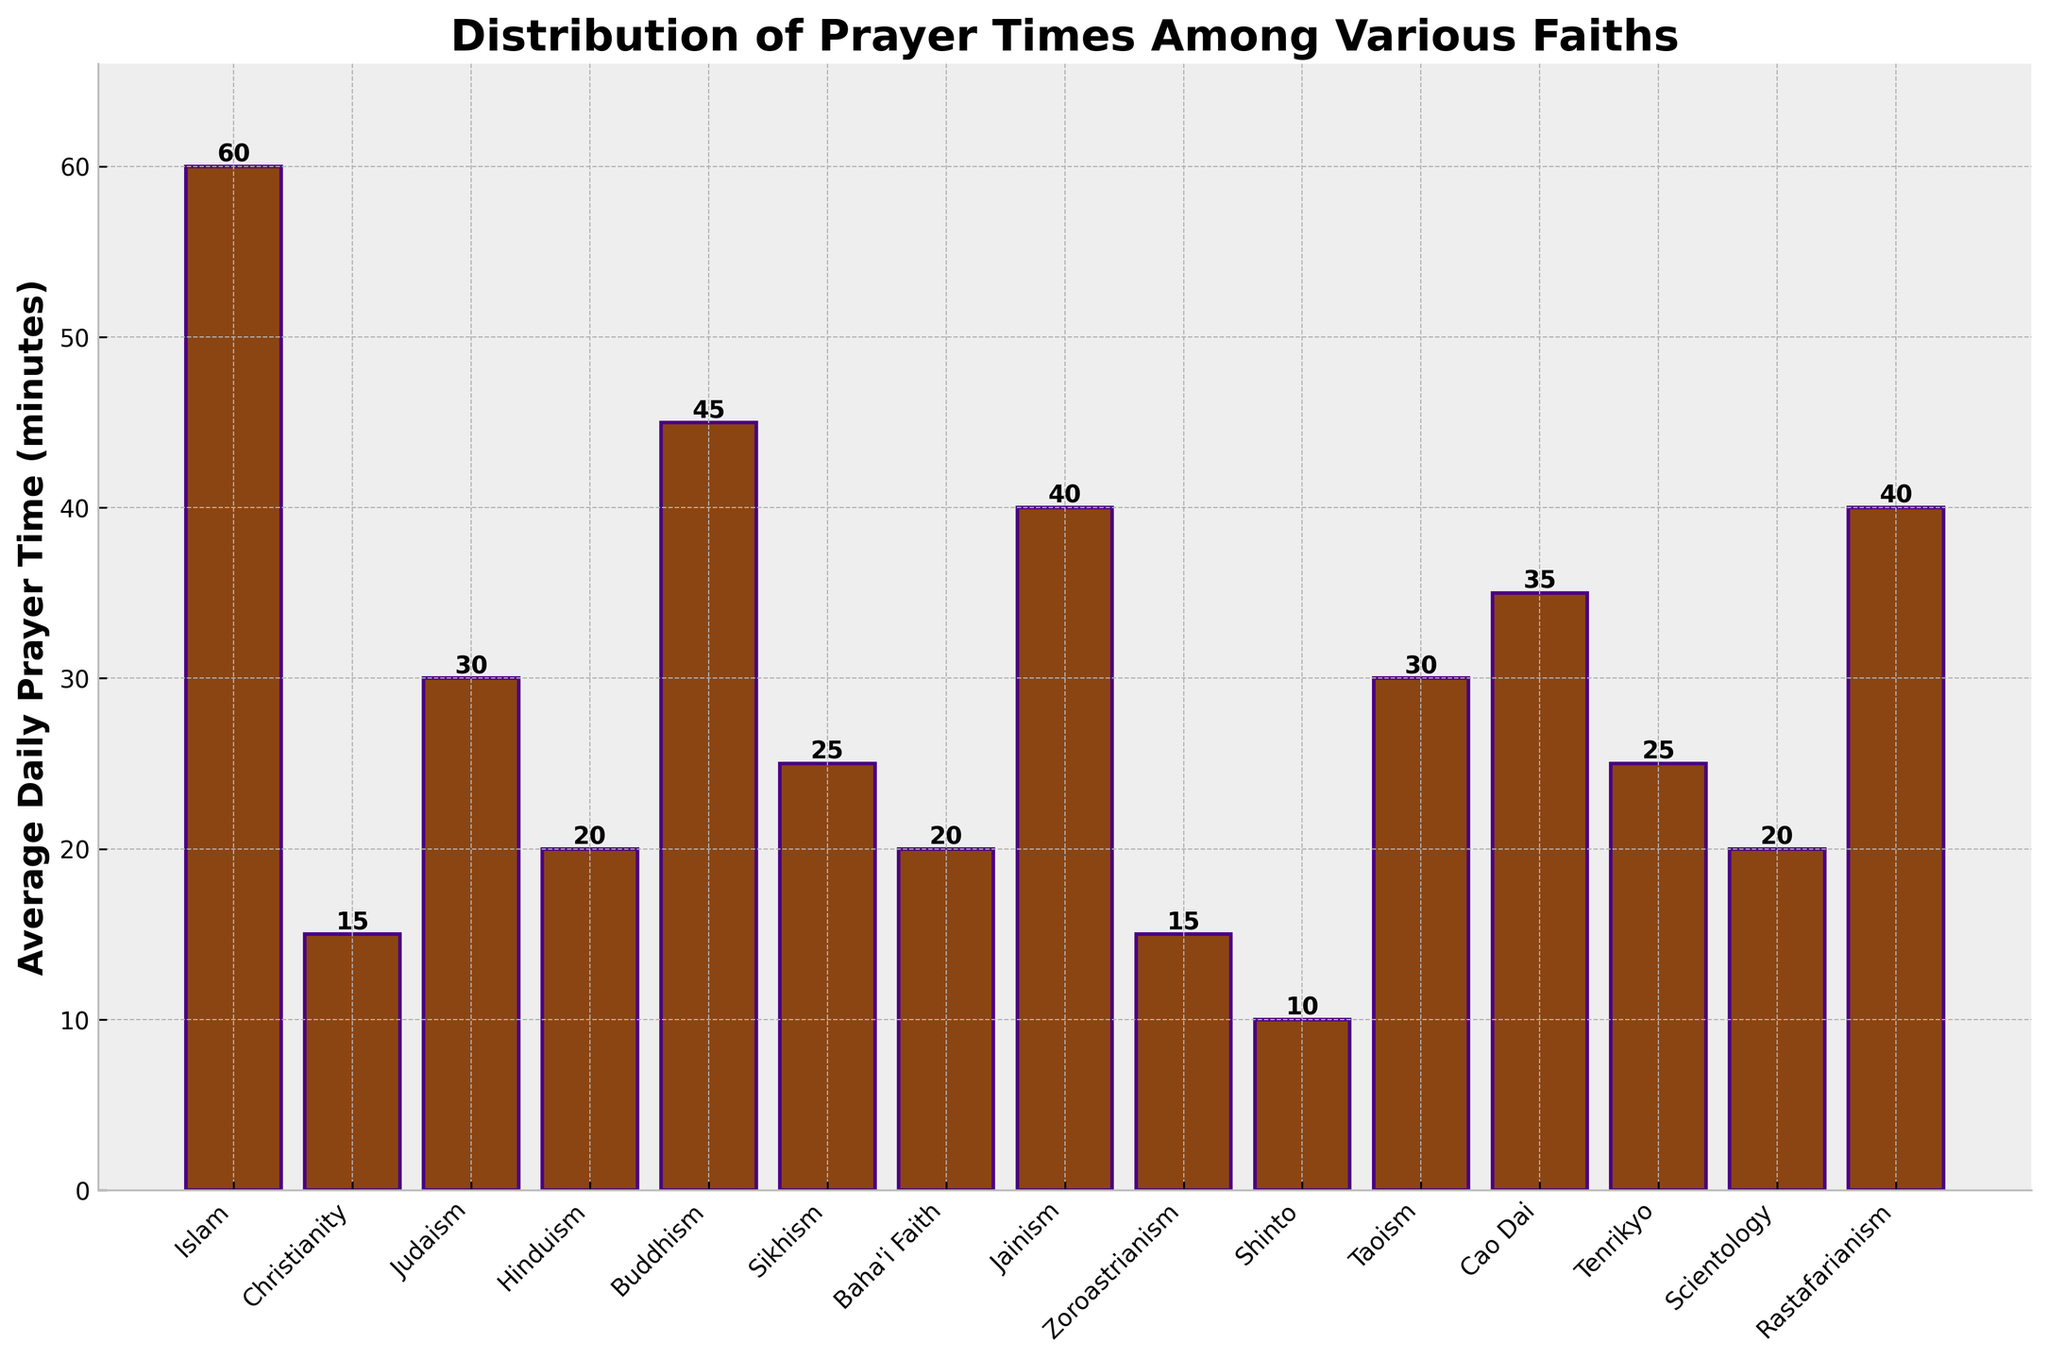What is the average daily prayer time for Islam? Look at the bar corresponding to Islam and read the height value, which represents the average daily prayer time in minutes.
Answer: 60 Which faith practices the least amount of daily prayer time on average? Identify the shortest bar in the chart, which represents the faith with the least average daily prayer time.
Answer: Shinto How much longer do Buddhists pray daily compared to Christians? Subtract the average daily prayer time of Christianity from that of Buddhism: 45 minutes (Buddhism) - 15 minutes (Christianity) = 30 minutes.
Answer: 30 Which faiths have an average daily prayer time of 20 minutes? Identify the bars that have a height of 20 minutes and list their corresponding faiths.
Answer: Hinduism, Baha'i Faith, Scientology What is the total average daily prayer time for Sikhism, Jainism, and Cao Dai combined? Add the average daily prayer times: 25 minutes (Sikhism) + 40 minutes (Jainism) + 35 minutes (Cao Dai) = 100 minutes.
Answer: 100 Rank the top three faiths with the highest average daily prayer times. Order the bars from tallest to shortest and select the three highest, which correspond to the faiths with the highest average daily prayer times.
Answer: Islam, Buddhism, Jainism Is the average prayer time for Taoism equal to that of Judaism? Compare the heights of the bars for Taoism and Judaism to see if they are the same. Both bars reach 30 minutes.
Answer: Yes What is the median average daily prayer time across all the faiths listed? List all the average daily prayer times in ascending order and identify the middle value(s): [10, 15, 15, 20, 20, 20, 25, 25, 30, 30, 35, 40, 40, 45, 60]. For an odd number of observations, it's the middle value. In this case, the middle value (8th value) is 25.
Answer: 25 How many faiths have an average daily prayer time of more than 30 minutes? Count the number of bars with heights greater than 30 minutes.
Answer: 5 Compare the average daily prayer times of Zoroastrianism and Rastafarianism in terms of percentage increase. Calculate the percentage increase from Zoroastrianism (15 minutes) to Rastafarianism (40 minutes) using the formula: [(40 - 15) / 15] * 100% = 166.67%
Answer: 166.67% 